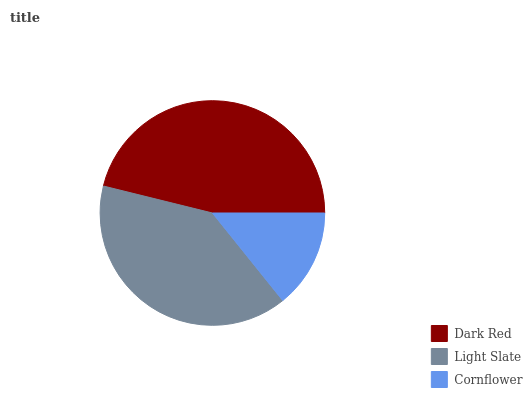Is Cornflower the minimum?
Answer yes or no. Yes. Is Dark Red the maximum?
Answer yes or no. Yes. Is Light Slate the minimum?
Answer yes or no. No. Is Light Slate the maximum?
Answer yes or no. No. Is Dark Red greater than Light Slate?
Answer yes or no. Yes. Is Light Slate less than Dark Red?
Answer yes or no. Yes. Is Light Slate greater than Dark Red?
Answer yes or no. No. Is Dark Red less than Light Slate?
Answer yes or no. No. Is Light Slate the high median?
Answer yes or no. Yes. Is Light Slate the low median?
Answer yes or no. Yes. Is Dark Red the high median?
Answer yes or no. No. Is Dark Red the low median?
Answer yes or no. No. 